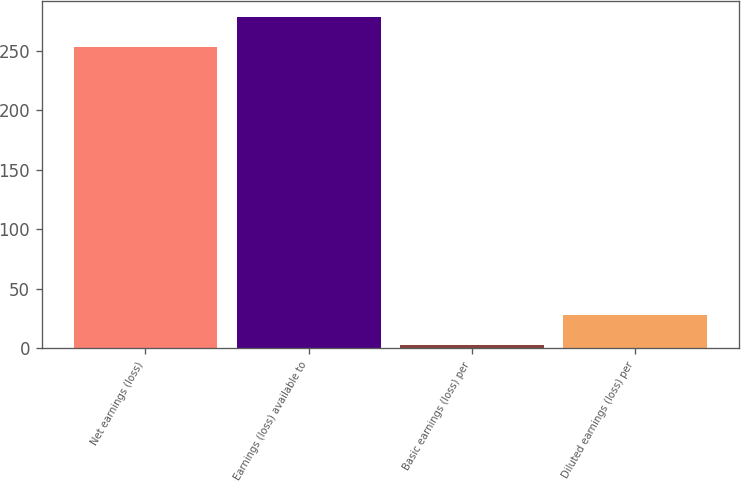Convert chart. <chart><loc_0><loc_0><loc_500><loc_500><bar_chart><fcel>Net earnings (loss)<fcel>Earnings (loss) available to<fcel>Basic earnings (loss) per<fcel>Diluted earnings (loss) per<nl><fcel>253<fcel>278.05<fcel>2.55<fcel>27.6<nl></chart> 